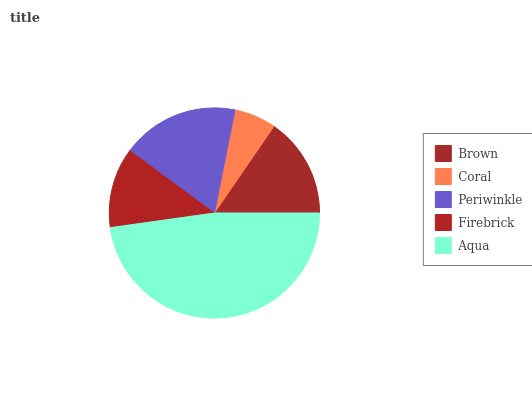Is Coral the minimum?
Answer yes or no. Yes. Is Aqua the maximum?
Answer yes or no. Yes. Is Periwinkle the minimum?
Answer yes or no. No. Is Periwinkle the maximum?
Answer yes or no. No. Is Periwinkle greater than Coral?
Answer yes or no. Yes. Is Coral less than Periwinkle?
Answer yes or no. Yes. Is Coral greater than Periwinkle?
Answer yes or no. No. Is Periwinkle less than Coral?
Answer yes or no. No. Is Brown the high median?
Answer yes or no. Yes. Is Brown the low median?
Answer yes or no. Yes. Is Periwinkle the high median?
Answer yes or no. No. Is Aqua the low median?
Answer yes or no. No. 